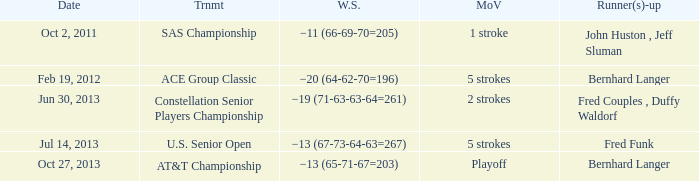Who's the Runner(s)-up with a Winning score of −19 (71-63-63-64=261)? Fred Couples , Duffy Waldorf. 